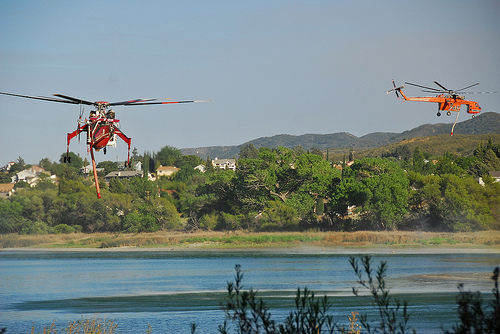<image>
Can you confirm if the water is under the drone? Yes. The water is positioned underneath the drone, with the drone above it in the vertical space. 